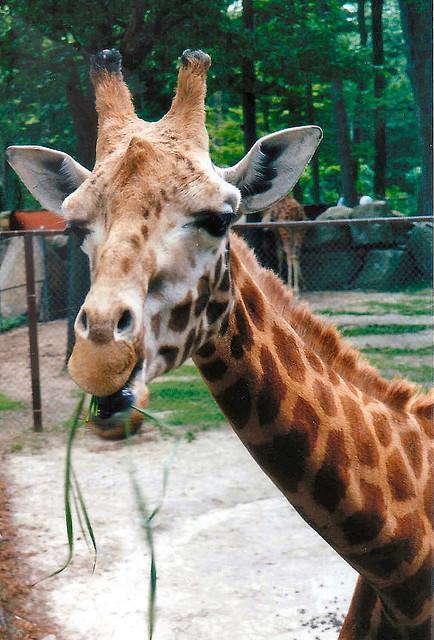How many giraffes are there?
Give a very brief answer. 2. 